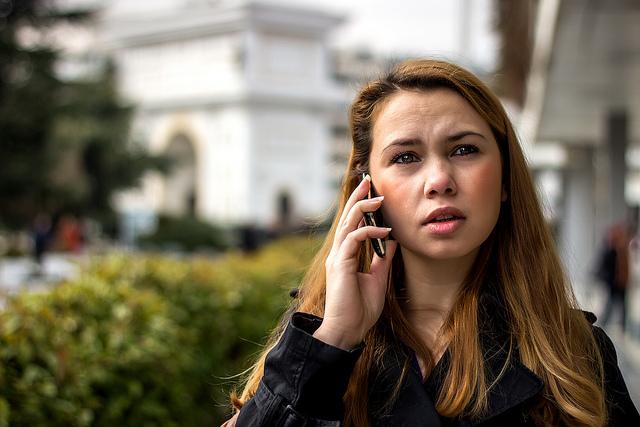What is the women holding?
Keep it brief. Phone. Is the woman smiling?
Give a very brief answer. No. Is the woman wearing sunglasses?
Answer briefly. No. Does the woman look worried?
Give a very brief answer. Yes. Is this person wearing glasses?
Concise answer only. No. Does the female look angry?
Keep it brief. No. What color is the woman's shirt?
Keep it brief. Black. What is she  holding?
Quick response, please. Phone. Is the woman overweight?
Concise answer only. No. Does she have straight hair?
Concise answer only. Yes. What is the girl doing?
Answer briefly. Talking. What is on the woman's wrist?
Write a very short answer. Sleeve. What is this person holding?
Short answer required. Cell phone. 